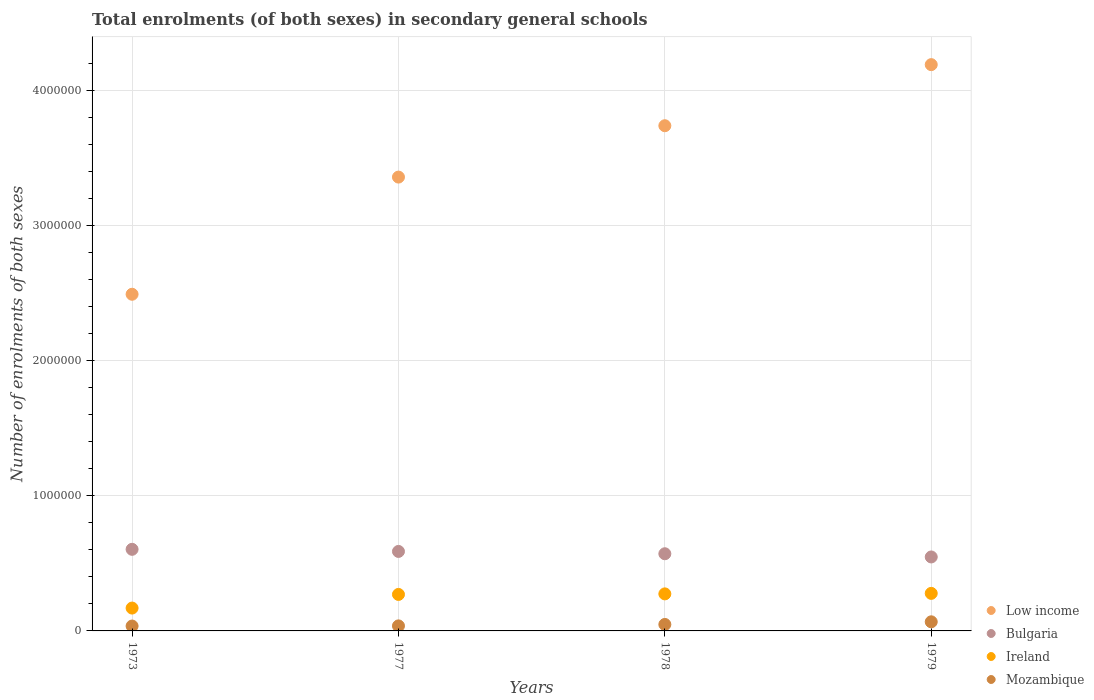Is the number of dotlines equal to the number of legend labels?
Your answer should be compact. Yes. What is the number of enrolments in secondary schools in Ireland in 1973?
Ensure brevity in your answer.  1.69e+05. Across all years, what is the maximum number of enrolments in secondary schools in Mozambique?
Your answer should be very brief. 6.74e+04. Across all years, what is the minimum number of enrolments in secondary schools in Low income?
Give a very brief answer. 2.49e+06. In which year was the number of enrolments in secondary schools in Ireland maximum?
Provide a short and direct response. 1979. What is the total number of enrolments in secondary schools in Bulgaria in the graph?
Your response must be concise. 2.31e+06. What is the difference between the number of enrolments in secondary schools in Ireland in 1973 and that in 1979?
Give a very brief answer. -1.09e+05. What is the difference between the number of enrolments in secondary schools in Ireland in 1979 and the number of enrolments in secondary schools in Low income in 1977?
Your answer should be compact. -3.08e+06. What is the average number of enrolments in secondary schools in Bulgaria per year?
Keep it short and to the point. 5.78e+05. In the year 1973, what is the difference between the number of enrolments in secondary schools in Ireland and number of enrolments in secondary schools in Low income?
Make the answer very short. -2.32e+06. In how many years, is the number of enrolments in secondary schools in Low income greater than 2000000?
Offer a very short reply. 4. What is the ratio of the number of enrolments in secondary schools in Ireland in 1977 to that in 1978?
Give a very brief answer. 0.99. What is the difference between the highest and the second highest number of enrolments in secondary schools in Mozambique?
Offer a terse response. 1.95e+04. What is the difference between the highest and the lowest number of enrolments in secondary schools in Bulgaria?
Your response must be concise. 5.65e+04. In how many years, is the number of enrolments in secondary schools in Ireland greater than the average number of enrolments in secondary schools in Ireland taken over all years?
Provide a short and direct response. 3. Is the sum of the number of enrolments in secondary schools in Low income in 1973 and 1979 greater than the maximum number of enrolments in secondary schools in Mozambique across all years?
Ensure brevity in your answer.  Yes. Is the number of enrolments in secondary schools in Ireland strictly less than the number of enrolments in secondary schools in Mozambique over the years?
Your answer should be compact. No. How many dotlines are there?
Your answer should be very brief. 4. How many years are there in the graph?
Your answer should be very brief. 4. Does the graph contain any zero values?
Your answer should be very brief. No. How many legend labels are there?
Provide a short and direct response. 4. How are the legend labels stacked?
Your answer should be very brief. Vertical. What is the title of the graph?
Your answer should be compact. Total enrolments (of both sexes) in secondary general schools. Does "Uganda" appear as one of the legend labels in the graph?
Your response must be concise. No. What is the label or title of the Y-axis?
Provide a short and direct response. Number of enrolments of both sexes. What is the Number of enrolments of both sexes of Low income in 1973?
Ensure brevity in your answer.  2.49e+06. What is the Number of enrolments of both sexes of Bulgaria in 1973?
Your response must be concise. 6.04e+05. What is the Number of enrolments of both sexes of Ireland in 1973?
Your answer should be very brief. 1.69e+05. What is the Number of enrolments of both sexes of Mozambique in 1973?
Make the answer very short. 3.62e+04. What is the Number of enrolments of both sexes of Low income in 1977?
Give a very brief answer. 3.36e+06. What is the Number of enrolments of both sexes of Bulgaria in 1977?
Provide a short and direct response. 5.88e+05. What is the Number of enrolments of both sexes of Ireland in 1977?
Give a very brief answer. 2.70e+05. What is the Number of enrolments of both sexes in Mozambique in 1977?
Give a very brief answer. 3.73e+04. What is the Number of enrolments of both sexes of Low income in 1978?
Offer a very short reply. 3.74e+06. What is the Number of enrolments of both sexes of Bulgaria in 1978?
Offer a very short reply. 5.71e+05. What is the Number of enrolments of both sexes in Ireland in 1978?
Provide a succinct answer. 2.74e+05. What is the Number of enrolments of both sexes of Mozambique in 1978?
Provide a succinct answer. 4.79e+04. What is the Number of enrolments of both sexes of Low income in 1979?
Provide a succinct answer. 4.19e+06. What is the Number of enrolments of both sexes of Bulgaria in 1979?
Offer a very short reply. 5.48e+05. What is the Number of enrolments of both sexes of Ireland in 1979?
Give a very brief answer. 2.78e+05. What is the Number of enrolments of both sexes of Mozambique in 1979?
Your answer should be compact. 6.74e+04. Across all years, what is the maximum Number of enrolments of both sexes of Low income?
Ensure brevity in your answer.  4.19e+06. Across all years, what is the maximum Number of enrolments of both sexes of Bulgaria?
Offer a very short reply. 6.04e+05. Across all years, what is the maximum Number of enrolments of both sexes in Ireland?
Your answer should be very brief. 2.78e+05. Across all years, what is the maximum Number of enrolments of both sexes of Mozambique?
Offer a terse response. 6.74e+04. Across all years, what is the minimum Number of enrolments of both sexes of Low income?
Give a very brief answer. 2.49e+06. Across all years, what is the minimum Number of enrolments of both sexes of Bulgaria?
Offer a terse response. 5.48e+05. Across all years, what is the minimum Number of enrolments of both sexes of Ireland?
Your response must be concise. 1.69e+05. Across all years, what is the minimum Number of enrolments of both sexes in Mozambique?
Ensure brevity in your answer.  3.62e+04. What is the total Number of enrolments of both sexes in Low income in the graph?
Provide a succinct answer. 1.38e+07. What is the total Number of enrolments of both sexes of Bulgaria in the graph?
Your answer should be very brief. 2.31e+06. What is the total Number of enrolments of both sexes in Ireland in the graph?
Offer a very short reply. 9.91e+05. What is the total Number of enrolments of both sexes in Mozambique in the graph?
Make the answer very short. 1.89e+05. What is the difference between the Number of enrolments of both sexes in Low income in 1973 and that in 1977?
Offer a terse response. -8.67e+05. What is the difference between the Number of enrolments of both sexes of Bulgaria in 1973 and that in 1977?
Your answer should be very brief. 1.56e+04. What is the difference between the Number of enrolments of both sexes in Ireland in 1973 and that in 1977?
Provide a short and direct response. -1.01e+05. What is the difference between the Number of enrolments of both sexes in Mozambique in 1973 and that in 1977?
Your answer should be compact. -1100. What is the difference between the Number of enrolments of both sexes in Low income in 1973 and that in 1978?
Your answer should be very brief. -1.25e+06. What is the difference between the Number of enrolments of both sexes of Bulgaria in 1973 and that in 1978?
Offer a very short reply. 3.28e+04. What is the difference between the Number of enrolments of both sexes in Ireland in 1973 and that in 1978?
Offer a terse response. -1.05e+05. What is the difference between the Number of enrolments of both sexes in Mozambique in 1973 and that in 1978?
Offer a very short reply. -1.17e+04. What is the difference between the Number of enrolments of both sexes in Low income in 1973 and that in 1979?
Ensure brevity in your answer.  -1.70e+06. What is the difference between the Number of enrolments of both sexes in Bulgaria in 1973 and that in 1979?
Offer a very short reply. 5.65e+04. What is the difference between the Number of enrolments of both sexes of Ireland in 1973 and that in 1979?
Ensure brevity in your answer.  -1.09e+05. What is the difference between the Number of enrolments of both sexes in Mozambique in 1973 and that in 1979?
Your answer should be compact. -3.13e+04. What is the difference between the Number of enrolments of both sexes in Low income in 1977 and that in 1978?
Make the answer very short. -3.80e+05. What is the difference between the Number of enrolments of both sexes of Bulgaria in 1977 and that in 1978?
Your response must be concise. 1.72e+04. What is the difference between the Number of enrolments of both sexes of Ireland in 1977 and that in 1978?
Offer a very short reply. -4082. What is the difference between the Number of enrolments of both sexes in Mozambique in 1977 and that in 1978?
Ensure brevity in your answer.  -1.06e+04. What is the difference between the Number of enrolments of both sexes in Low income in 1977 and that in 1979?
Your answer should be very brief. -8.32e+05. What is the difference between the Number of enrolments of both sexes in Bulgaria in 1977 and that in 1979?
Your answer should be compact. 4.09e+04. What is the difference between the Number of enrolments of both sexes in Ireland in 1977 and that in 1979?
Offer a very short reply. -7823. What is the difference between the Number of enrolments of both sexes in Mozambique in 1977 and that in 1979?
Offer a very short reply. -3.02e+04. What is the difference between the Number of enrolments of both sexes of Low income in 1978 and that in 1979?
Offer a terse response. -4.52e+05. What is the difference between the Number of enrolments of both sexes in Bulgaria in 1978 and that in 1979?
Ensure brevity in your answer.  2.37e+04. What is the difference between the Number of enrolments of both sexes in Ireland in 1978 and that in 1979?
Your answer should be compact. -3741. What is the difference between the Number of enrolments of both sexes in Mozambique in 1978 and that in 1979?
Keep it short and to the point. -1.95e+04. What is the difference between the Number of enrolments of both sexes in Low income in 1973 and the Number of enrolments of both sexes in Bulgaria in 1977?
Your answer should be compact. 1.90e+06. What is the difference between the Number of enrolments of both sexes of Low income in 1973 and the Number of enrolments of both sexes of Ireland in 1977?
Provide a short and direct response. 2.22e+06. What is the difference between the Number of enrolments of both sexes of Low income in 1973 and the Number of enrolments of both sexes of Mozambique in 1977?
Offer a terse response. 2.45e+06. What is the difference between the Number of enrolments of both sexes in Bulgaria in 1973 and the Number of enrolments of both sexes in Ireland in 1977?
Give a very brief answer. 3.34e+05. What is the difference between the Number of enrolments of both sexes in Bulgaria in 1973 and the Number of enrolments of both sexes in Mozambique in 1977?
Your answer should be very brief. 5.67e+05. What is the difference between the Number of enrolments of both sexes in Ireland in 1973 and the Number of enrolments of both sexes in Mozambique in 1977?
Your answer should be very brief. 1.32e+05. What is the difference between the Number of enrolments of both sexes in Low income in 1973 and the Number of enrolments of both sexes in Bulgaria in 1978?
Give a very brief answer. 1.92e+06. What is the difference between the Number of enrolments of both sexes in Low income in 1973 and the Number of enrolments of both sexes in Ireland in 1978?
Offer a very short reply. 2.22e+06. What is the difference between the Number of enrolments of both sexes in Low income in 1973 and the Number of enrolments of both sexes in Mozambique in 1978?
Offer a very short reply. 2.44e+06. What is the difference between the Number of enrolments of both sexes of Bulgaria in 1973 and the Number of enrolments of both sexes of Ireland in 1978?
Ensure brevity in your answer.  3.30e+05. What is the difference between the Number of enrolments of both sexes of Bulgaria in 1973 and the Number of enrolments of both sexes of Mozambique in 1978?
Offer a terse response. 5.56e+05. What is the difference between the Number of enrolments of both sexes of Ireland in 1973 and the Number of enrolments of both sexes of Mozambique in 1978?
Keep it short and to the point. 1.21e+05. What is the difference between the Number of enrolments of both sexes of Low income in 1973 and the Number of enrolments of both sexes of Bulgaria in 1979?
Offer a very short reply. 1.94e+06. What is the difference between the Number of enrolments of both sexes in Low income in 1973 and the Number of enrolments of both sexes in Ireland in 1979?
Your answer should be compact. 2.21e+06. What is the difference between the Number of enrolments of both sexes of Low income in 1973 and the Number of enrolments of both sexes of Mozambique in 1979?
Keep it short and to the point. 2.42e+06. What is the difference between the Number of enrolments of both sexes of Bulgaria in 1973 and the Number of enrolments of both sexes of Ireland in 1979?
Keep it short and to the point. 3.26e+05. What is the difference between the Number of enrolments of both sexes of Bulgaria in 1973 and the Number of enrolments of both sexes of Mozambique in 1979?
Your answer should be very brief. 5.37e+05. What is the difference between the Number of enrolments of both sexes in Ireland in 1973 and the Number of enrolments of both sexes in Mozambique in 1979?
Ensure brevity in your answer.  1.02e+05. What is the difference between the Number of enrolments of both sexes of Low income in 1977 and the Number of enrolments of both sexes of Bulgaria in 1978?
Your answer should be very brief. 2.79e+06. What is the difference between the Number of enrolments of both sexes in Low income in 1977 and the Number of enrolments of both sexes in Ireland in 1978?
Give a very brief answer. 3.09e+06. What is the difference between the Number of enrolments of both sexes in Low income in 1977 and the Number of enrolments of both sexes in Mozambique in 1978?
Ensure brevity in your answer.  3.31e+06. What is the difference between the Number of enrolments of both sexes in Bulgaria in 1977 and the Number of enrolments of both sexes in Ireland in 1978?
Provide a succinct answer. 3.14e+05. What is the difference between the Number of enrolments of both sexes of Bulgaria in 1977 and the Number of enrolments of both sexes of Mozambique in 1978?
Your response must be concise. 5.41e+05. What is the difference between the Number of enrolments of both sexes in Ireland in 1977 and the Number of enrolments of both sexes in Mozambique in 1978?
Provide a succinct answer. 2.22e+05. What is the difference between the Number of enrolments of both sexes of Low income in 1977 and the Number of enrolments of both sexes of Bulgaria in 1979?
Provide a short and direct response. 2.81e+06. What is the difference between the Number of enrolments of both sexes of Low income in 1977 and the Number of enrolments of both sexes of Ireland in 1979?
Keep it short and to the point. 3.08e+06. What is the difference between the Number of enrolments of both sexes in Low income in 1977 and the Number of enrolments of both sexes in Mozambique in 1979?
Provide a succinct answer. 3.29e+06. What is the difference between the Number of enrolments of both sexes in Bulgaria in 1977 and the Number of enrolments of both sexes in Ireland in 1979?
Keep it short and to the point. 3.10e+05. What is the difference between the Number of enrolments of both sexes of Bulgaria in 1977 and the Number of enrolments of both sexes of Mozambique in 1979?
Make the answer very short. 5.21e+05. What is the difference between the Number of enrolments of both sexes in Ireland in 1977 and the Number of enrolments of both sexes in Mozambique in 1979?
Ensure brevity in your answer.  2.03e+05. What is the difference between the Number of enrolments of both sexes of Low income in 1978 and the Number of enrolments of both sexes of Bulgaria in 1979?
Provide a short and direct response. 3.19e+06. What is the difference between the Number of enrolments of both sexes of Low income in 1978 and the Number of enrolments of both sexes of Ireland in 1979?
Offer a very short reply. 3.46e+06. What is the difference between the Number of enrolments of both sexes in Low income in 1978 and the Number of enrolments of both sexes in Mozambique in 1979?
Make the answer very short. 3.67e+06. What is the difference between the Number of enrolments of both sexes of Bulgaria in 1978 and the Number of enrolments of both sexes of Ireland in 1979?
Your answer should be compact. 2.93e+05. What is the difference between the Number of enrolments of both sexes of Bulgaria in 1978 and the Number of enrolments of both sexes of Mozambique in 1979?
Your answer should be very brief. 5.04e+05. What is the difference between the Number of enrolments of both sexes of Ireland in 1978 and the Number of enrolments of both sexes of Mozambique in 1979?
Provide a short and direct response. 2.07e+05. What is the average Number of enrolments of both sexes of Low income per year?
Provide a succinct answer. 3.45e+06. What is the average Number of enrolments of both sexes in Bulgaria per year?
Provide a succinct answer. 5.78e+05. What is the average Number of enrolments of both sexes in Ireland per year?
Your answer should be compact. 2.48e+05. What is the average Number of enrolments of both sexes in Mozambique per year?
Ensure brevity in your answer.  4.72e+04. In the year 1973, what is the difference between the Number of enrolments of both sexes of Low income and Number of enrolments of both sexes of Bulgaria?
Keep it short and to the point. 1.89e+06. In the year 1973, what is the difference between the Number of enrolments of both sexes of Low income and Number of enrolments of both sexes of Ireland?
Offer a very short reply. 2.32e+06. In the year 1973, what is the difference between the Number of enrolments of both sexes of Low income and Number of enrolments of both sexes of Mozambique?
Give a very brief answer. 2.46e+06. In the year 1973, what is the difference between the Number of enrolments of both sexes in Bulgaria and Number of enrolments of both sexes in Ireland?
Offer a terse response. 4.35e+05. In the year 1973, what is the difference between the Number of enrolments of both sexes in Bulgaria and Number of enrolments of both sexes in Mozambique?
Your answer should be very brief. 5.68e+05. In the year 1973, what is the difference between the Number of enrolments of both sexes of Ireland and Number of enrolments of both sexes of Mozambique?
Keep it short and to the point. 1.33e+05. In the year 1977, what is the difference between the Number of enrolments of both sexes of Low income and Number of enrolments of both sexes of Bulgaria?
Make the answer very short. 2.77e+06. In the year 1977, what is the difference between the Number of enrolments of both sexes of Low income and Number of enrolments of both sexes of Ireland?
Make the answer very short. 3.09e+06. In the year 1977, what is the difference between the Number of enrolments of both sexes in Low income and Number of enrolments of both sexes in Mozambique?
Offer a very short reply. 3.32e+06. In the year 1977, what is the difference between the Number of enrolments of both sexes of Bulgaria and Number of enrolments of both sexes of Ireland?
Keep it short and to the point. 3.18e+05. In the year 1977, what is the difference between the Number of enrolments of both sexes in Bulgaria and Number of enrolments of both sexes in Mozambique?
Offer a terse response. 5.51e+05. In the year 1977, what is the difference between the Number of enrolments of both sexes in Ireland and Number of enrolments of both sexes in Mozambique?
Provide a short and direct response. 2.33e+05. In the year 1978, what is the difference between the Number of enrolments of both sexes of Low income and Number of enrolments of both sexes of Bulgaria?
Offer a terse response. 3.17e+06. In the year 1978, what is the difference between the Number of enrolments of both sexes in Low income and Number of enrolments of both sexes in Ireland?
Offer a terse response. 3.47e+06. In the year 1978, what is the difference between the Number of enrolments of both sexes of Low income and Number of enrolments of both sexes of Mozambique?
Provide a succinct answer. 3.69e+06. In the year 1978, what is the difference between the Number of enrolments of both sexes in Bulgaria and Number of enrolments of both sexes in Ireland?
Your answer should be compact. 2.97e+05. In the year 1978, what is the difference between the Number of enrolments of both sexes in Bulgaria and Number of enrolments of both sexes in Mozambique?
Your response must be concise. 5.23e+05. In the year 1978, what is the difference between the Number of enrolments of both sexes in Ireland and Number of enrolments of both sexes in Mozambique?
Provide a succinct answer. 2.26e+05. In the year 1979, what is the difference between the Number of enrolments of both sexes of Low income and Number of enrolments of both sexes of Bulgaria?
Your answer should be compact. 3.64e+06. In the year 1979, what is the difference between the Number of enrolments of both sexes of Low income and Number of enrolments of both sexes of Ireland?
Provide a succinct answer. 3.91e+06. In the year 1979, what is the difference between the Number of enrolments of both sexes of Low income and Number of enrolments of both sexes of Mozambique?
Give a very brief answer. 4.12e+06. In the year 1979, what is the difference between the Number of enrolments of both sexes of Bulgaria and Number of enrolments of both sexes of Ireland?
Offer a very short reply. 2.70e+05. In the year 1979, what is the difference between the Number of enrolments of both sexes in Bulgaria and Number of enrolments of both sexes in Mozambique?
Give a very brief answer. 4.80e+05. In the year 1979, what is the difference between the Number of enrolments of both sexes of Ireland and Number of enrolments of both sexes of Mozambique?
Your response must be concise. 2.11e+05. What is the ratio of the Number of enrolments of both sexes of Low income in 1973 to that in 1977?
Provide a succinct answer. 0.74. What is the ratio of the Number of enrolments of both sexes in Bulgaria in 1973 to that in 1977?
Your answer should be compact. 1.03. What is the ratio of the Number of enrolments of both sexes of Ireland in 1973 to that in 1977?
Offer a very short reply. 0.63. What is the ratio of the Number of enrolments of both sexes of Mozambique in 1973 to that in 1977?
Your answer should be very brief. 0.97. What is the ratio of the Number of enrolments of both sexes in Low income in 1973 to that in 1978?
Your answer should be very brief. 0.67. What is the ratio of the Number of enrolments of both sexes in Bulgaria in 1973 to that in 1978?
Provide a short and direct response. 1.06. What is the ratio of the Number of enrolments of both sexes of Ireland in 1973 to that in 1978?
Keep it short and to the point. 0.62. What is the ratio of the Number of enrolments of both sexes in Mozambique in 1973 to that in 1978?
Your answer should be very brief. 0.76. What is the ratio of the Number of enrolments of both sexes of Low income in 1973 to that in 1979?
Keep it short and to the point. 0.59. What is the ratio of the Number of enrolments of both sexes in Bulgaria in 1973 to that in 1979?
Your answer should be compact. 1.1. What is the ratio of the Number of enrolments of both sexes in Ireland in 1973 to that in 1979?
Your response must be concise. 0.61. What is the ratio of the Number of enrolments of both sexes in Mozambique in 1973 to that in 1979?
Your answer should be very brief. 0.54. What is the ratio of the Number of enrolments of both sexes in Low income in 1977 to that in 1978?
Offer a very short reply. 0.9. What is the ratio of the Number of enrolments of both sexes in Bulgaria in 1977 to that in 1978?
Ensure brevity in your answer.  1.03. What is the ratio of the Number of enrolments of both sexes of Ireland in 1977 to that in 1978?
Your answer should be very brief. 0.99. What is the ratio of the Number of enrolments of both sexes in Mozambique in 1977 to that in 1978?
Keep it short and to the point. 0.78. What is the ratio of the Number of enrolments of both sexes in Low income in 1977 to that in 1979?
Make the answer very short. 0.8. What is the ratio of the Number of enrolments of both sexes of Bulgaria in 1977 to that in 1979?
Keep it short and to the point. 1.07. What is the ratio of the Number of enrolments of both sexes of Ireland in 1977 to that in 1979?
Provide a succinct answer. 0.97. What is the ratio of the Number of enrolments of both sexes in Mozambique in 1977 to that in 1979?
Make the answer very short. 0.55. What is the ratio of the Number of enrolments of both sexes of Low income in 1978 to that in 1979?
Provide a short and direct response. 0.89. What is the ratio of the Number of enrolments of both sexes in Bulgaria in 1978 to that in 1979?
Your answer should be compact. 1.04. What is the ratio of the Number of enrolments of both sexes of Ireland in 1978 to that in 1979?
Provide a succinct answer. 0.99. What is the ratio of the Number of enrolments of both sexes of Mozambique in 1978 to that in 1979?
Your answer should be compact. 0.71. What is the difference between the highest and the second highest Number of enrolments of both sexes of Low income?
Provide a short and direct response. 4.52e+05. What is the difference between the highest and the second highest Number of enrolments of both sexes in Bulgaria?
Your answer should be compact. 1.56e+04. What is the difference between the highest and the second highest Number of enrolments of both sexes of Ireland?
Provide a short and direct response. 3741. What is the difference between the highest and the second highest Number of enrolments of both sexes in Mozambique?
Your answer should be compact. 1.95e+04. What is the difference between the highest and the lowest Number of enrolments of both sexes of Low income?
Your answer should be very brief. 1.70e+06. What is the difference between the highest and the lowest Number of enrolments of both sexes of Bulgaria?
Give a very brief answer. 5.65e+04. What is the difference between the highest and the lowest Number of enrolments of both sexes of Ireland?
Provide a succinct answer. 1.09e+05. What is the difference between the highest and the lowest Number of enrolments of both sexes in Mozambique?
Make the answer very short. 3.13e+04. 